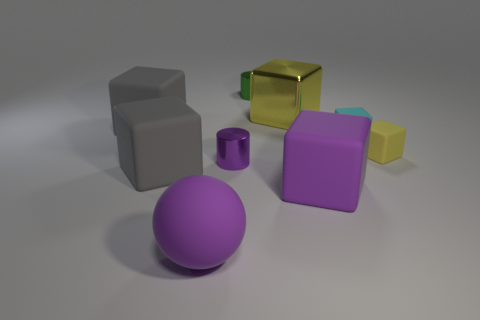There is a large rubber thing that is the same color as the rubber sphere; what shape is it?
Your response must be concise. Cube. There is a shiny cylinder in front of the small block to the right of the cyan block; what color is it?
Give a very brief answer. Purple. What color is the other tiny object that is the same shape as the tiny cyan object?
Provide a short and direct response. Yellow. What size is the purple metallic object that is the same shape as the small green metal object?
Offer a terse response. Small. There is a tiny cylinder in front of the small yellow rubber block; what is its material?
Provide a short and direct response. Metal. Is the number of gray things to the right of the cyan object less than the number of brown rubber cylinders?
Offer a terse response. No. What shape is the gray object that is on the right side of the gray rubber thing that is behind the cyan cube?
Your answer should be compact. Cube. What is the color of the sphere?
Give a very brief answer. Purple. What number of other things are the same size as the green metal thing?
Ensure brevity in your answer.  3. What material is the large block that is both on the right side of the tiny green metal cylinder and in front of the cyan cube?
Ensure brevity in your answer.  Rubber. 